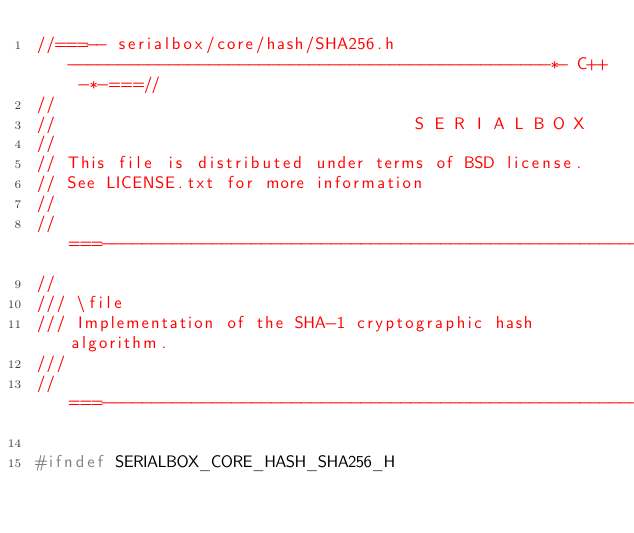Convert code to text. <code><loc_0><loc_0><loc_500><loc_500><_C_>//===-- serialbox/core/hash/SHA256.h ------------------------------------------------*- C++ -*-===//
//
//                                    S E R I A L B O X
//
// This file is distributed under terms of BSD license.
// See LICENSE.txt for more information
//
//===------------------------------------------------------------------------------------------===//
//
/// \file
/// Implementation of the SHA-1 cryptographic hash algorithm.
///
//===------------------------------------------------------------------------------------------===//

#ifndef SERIALBOX_CORE_HASH_SHA256_H</code> 